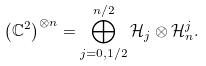<formula> <loc_0><loc_0><loc_500><loc_500>\left ( \mathbb { C } ^ { 2 } \right ) ^ { \otimes n } = \bigoplus _ { j = 0 , 1 / 2 } ^ { n / 2 } \mathcal { H } _ { j } \otimes \mathcal { H } ^ { j } _ { n } .</formula> 